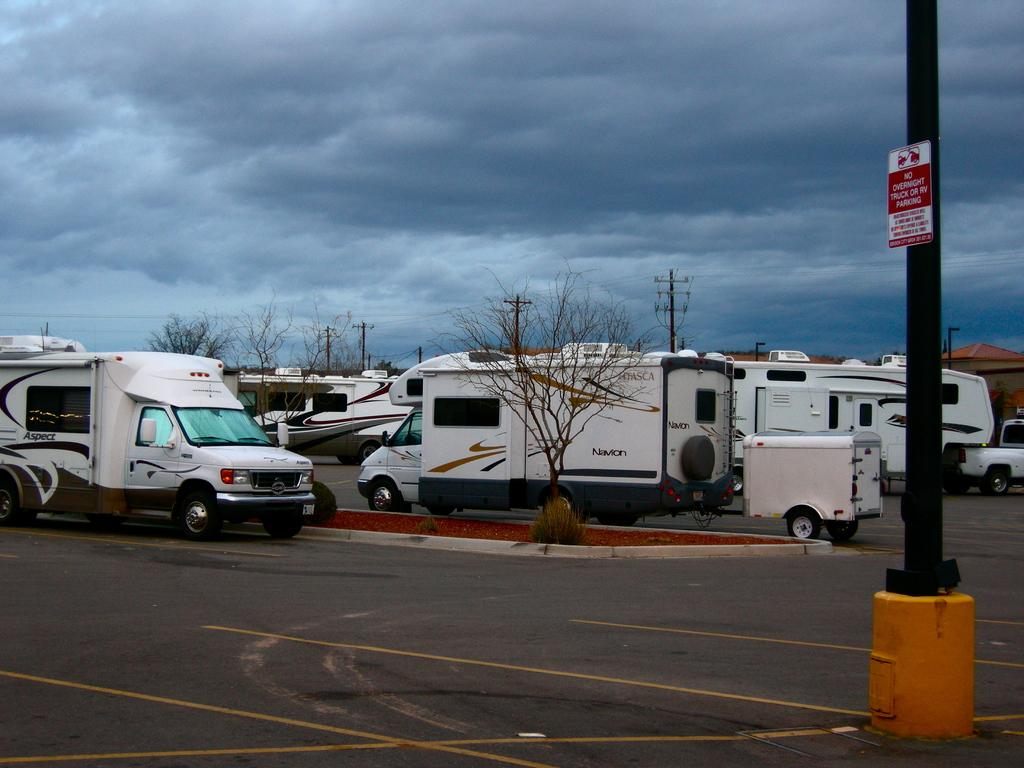What type of vehicles can be seen on the road in the image? There are vans on the road in the image. What structures are present alongside the road? There are electric poles in the image. What type of natural elements can be seen in the image? There are trees in the image. What is visible in the sky in the image? There are clouds visible at the top of the image. What object is located to the right side of the image? There is a pole to the right side of the image. How many chickens are crossing the road in the image? There are no chickens present in the image; it features vans on the road. What type of currency is visible in the image? There is no currency present in the image. 